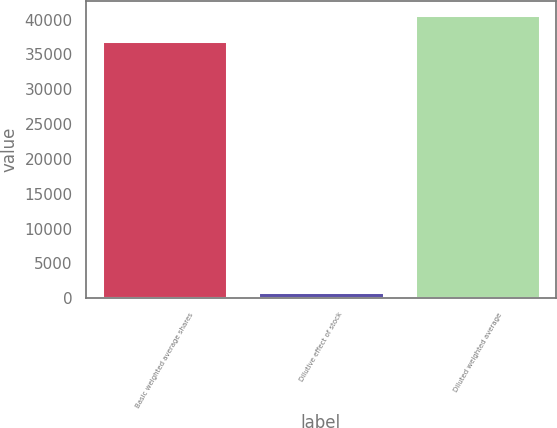Convert chart to OTSL. <chart><loc_0><loc_0><loc_500><loc_500><bar_chart><fcel>Basic weighted average shares<fcel>Dilutive effect of stock<fcel>Diluted weighted average<nl><fcel>36958<fcel>897<fcel>40653.8<nl></chart> 